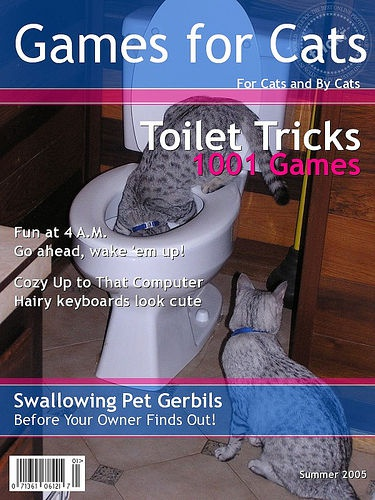Describe the objects in this image and their specific colors. I can see toilet in darkblue, gray, and lavender tones and cat in darkblue, gray, and black tones in this image. 